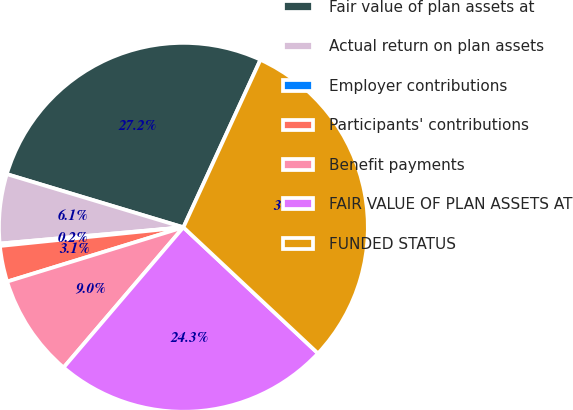<chart> <loc_0><loc_0><loc_500><loc_500><pie_chart><fcel>Fair value of plan assets at<fcel>Actual return on plan assets<fcel>Employer contributions<fcel>Participants' contributions<fcel>Benefit payments<fcel>FAIR VALUE OF PLAN ASSETS AT<fcel>FUNDED STATUS<nl><fcel>27.2%<fcel>6.06%<fcel>0.21%<fcel>3.14%<fcel>8.99%<fcel>24.27%<fcel>30.12%<nl></chart> 